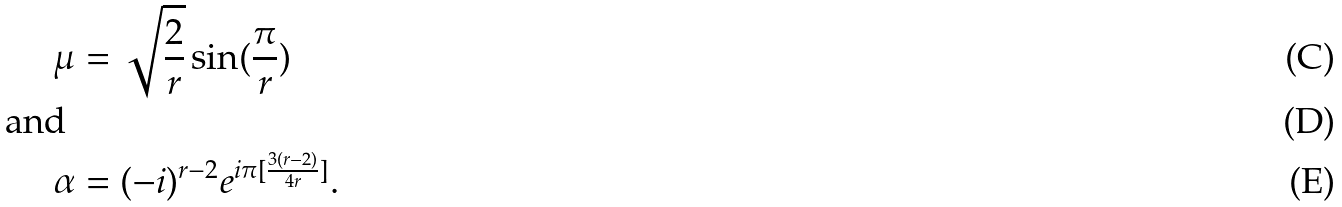Convert formula to latex. <formula><loc_0><loc_0><loc_500><loc_500>\mu & = \sqrt { \frac { 2 } { r } } \sin ( \frac { \pi } { r } ) \\ \text { and } \\ \alpha & = ( - i ) ^ { r - 2 } e ^ { i \pi [ \frac { 3 ( r - 2 ) } { 4 r } ] } .</formula> 